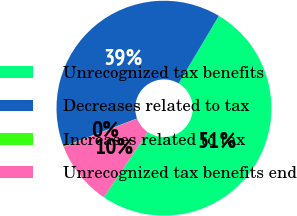<chart> <loc_0><loc_0><loc_500><loc_500><pie_chart><fcel>Unrecognized tax benefits<fcel>Decreases related to tax<fcel>Increases related to tax<fcel>Unrecognized tax benefits end<nl><fcel>50.92%<fcel>39.34%<fcel>0.07%<fcel>9.67%<nl></chart> 